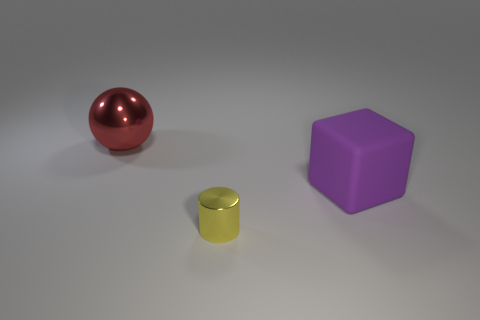Could you guess the purpose of these objects in this context? Without additional context, it's challenging to assign a definitive purpose. However, these objects could be part of a visual composition intended to study forms, materials, and shadows, or as models for a rendering software demonstration.  Are the objects producing any shadows or reflections? Yes, each object is casting a soft shadow on the surface below it, which helps to give a sense of spatial positioning and lighting direction. The sphere, with its glossy finish, also shows a highlight, indicating a strong light source within the environment. 